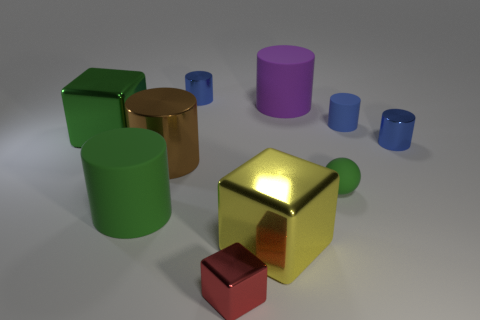Does the large yellow metal thing have the same shape as the small red metallic object? While the large yellow item and the small red item both appear to be cube-shaped, their identical geometric shape does not extend to size or color, with the former being larger and yellow, and the latter being smaller and red. 